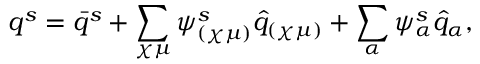Convert formula to latex. <formula><loc_0><loc_0><loc_500><loc_500>q ^ { s } = \bar { q } ^ { s } + \sum _ { \chi \mu } \psi _ { ( \chi \mu ) } ^ { s } \hat { q } _ { ( \chi \mu ) } + \sum _ { \alpha } \psi _ { \alpha } ^ { s } \hat { q } _ { \alpha } ,</formula> 